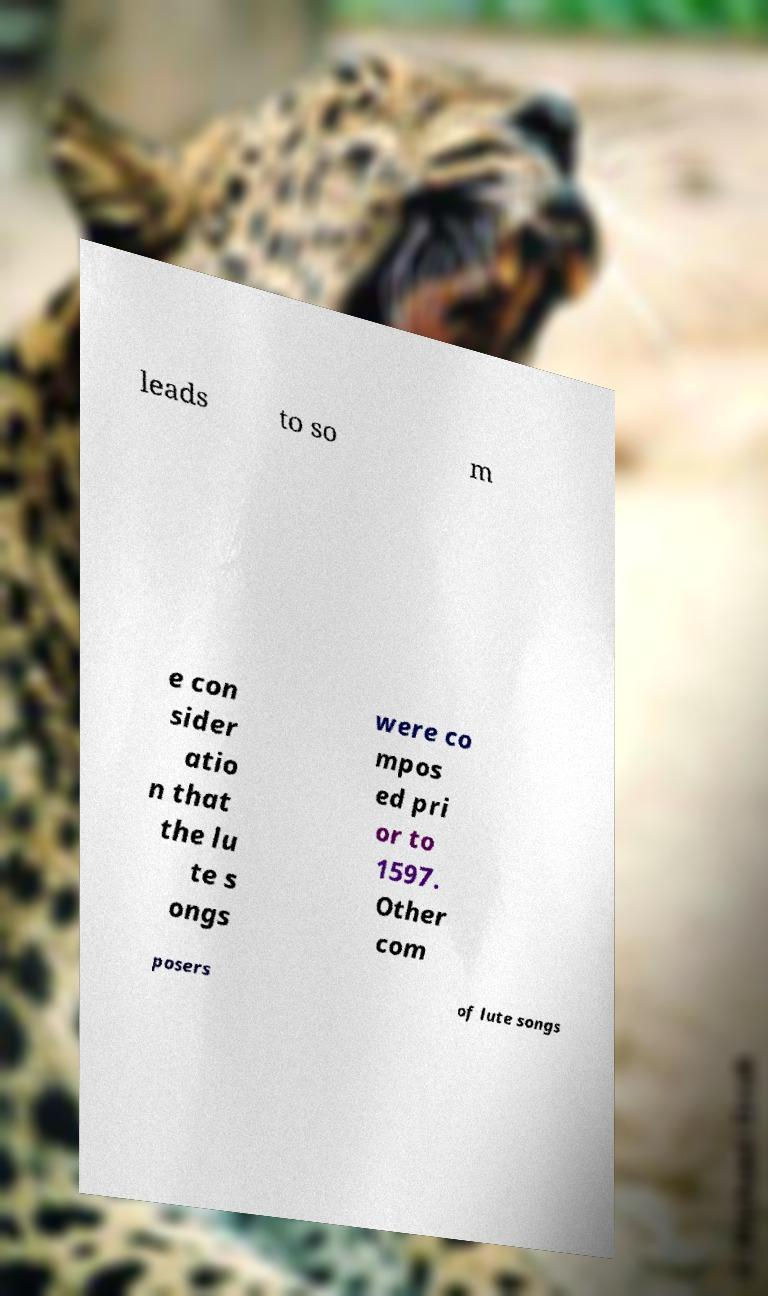Please identify and transcribe the text found in this image. leads to so m e con sider atio n that the lu te s ongs were co mpos ed pri or to 1597. Other com posers of lute songs 